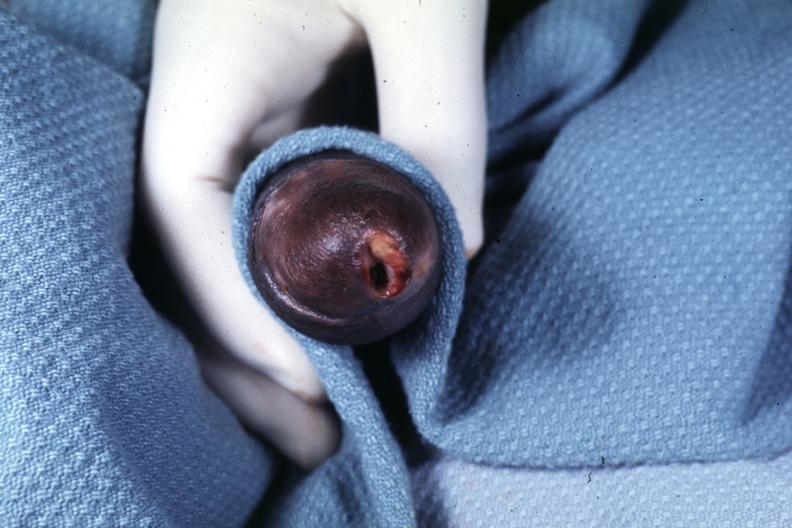does this image show glans ulcer probable herpes?
Answer the question using a single word or phrase. Yes 